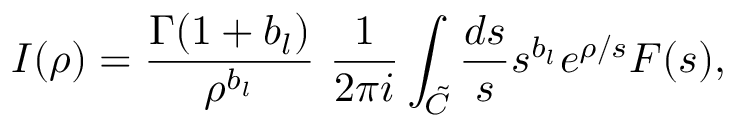Convert formula to latex. <formula><loc_0><loc_0><loc_500><loc_500>I ( \rho ) = \frac { \Gamma ( 1 + b _ { l } ) } { \rho ^ { b _ { l } } } \ \frac { 1 } { 2 \pi i } \int _ { \tilde { C } } \frac { d s } { s } s ^ { b _ { l } } e ^ { \rho / s } F ( s ) ,</formula> 